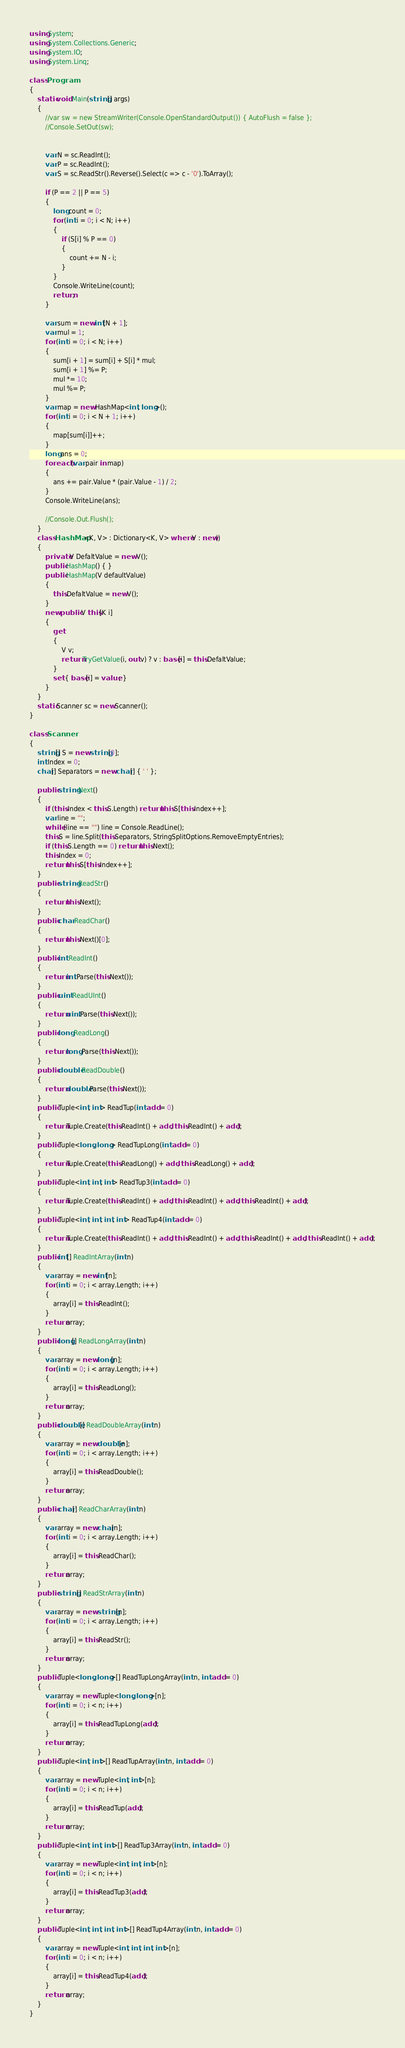<code> <loc_0><loc_0><loc_500><loc_500><_C#_>using System;
using System.Collections.Generic;
using System.IO;
using System.Linq;

class Program
{
    static void Main(string[] args)
    {
        //var sw = new StreamWriter(Console.OpenStandardOutput()) { AutoFlush = false };
        //Console.SetOut(sw);


        var N = sc.ReadInt();
        var P = sc.ReadInt();
        var S = sc.ReadStr().Reverse().Select(c => c - '0').ToArray();

        if (P == 2 || P == 5)
        {
            long count = 0;
            for (int i = 0; i < N; i++)
            {
                if (S[i] % P == 0)
                {
                    count += N - i;
                }
            }
            Console.WriteLine(count);
            return;
        }

        var sum = new int[N + 1];
        var mul = 1;
        for (int i = 0; i < N; i++)
        {
            sum[i + 1] = sum[i] + S[i] * mul;
            sum[i + 1] %= P;
            mul *= 10;
            mul %= P;
        }
        var map = new HashMap<int, long>();
        for (int i = 0; i < N + 1; i++)
        {
            map[sum[i]]++;
        }
        long ans = 0;
        foreach (var pair in map)
        {
            ans += pair.Value * (pair.Value - 1) / 2;
        }
        Console.WriteLine(ans);

        //Console.Out.Flush();
    }
    class HashMap<K, V> : Dictionary<K, V> where V : new()
    {
        private V DefaltValue = new V();
        public HashMap() { }
        public HashMap(V defaultValue)
        {
            this.DefaltValue = new V();
        }
        new public V this[K i]
        {
            get
            {
                V v;
                return TryGetValue(i, out v) ? v : base[i] = this.DefaltValue;
            }
            set { base[i] = value; }
        }
    }
    static Scanner sc = new Scanner();
}

class Scanner
{
    string[] S = new string[0];
    int Index = 0;
    char[] Separators = new char[] { ' ' };

    public string Next()
    {
        if (this.Index < this.S.Length) return this.S[this.Index++];
        var line = "";
        while (line == "") line = Console.ReadLine();
        this.S = line.Split(this.Separators, StringSplitOptions.RemoveEmptyEntries);
        if (this.S.Length == 0) return this.Next();
        this.Index = 0;
        return this.S[this.Index++];
    }
    public string ReadStr()
    {
        return this.Next();
    }
    public char ReadChar()
    {
        return this.Next()[0];
    }
    public int ReadInt()
    {
        return int.Parse(this.Next());
    }
    public uint ReadUInt()
    {
        return uint.Parse(this.Next());
    }
    public long ReadLong()
    {
        return long.Parse(this.Next());
    }
    public double ReadDouble()
    {
        return double.Parse(this.Next());
    }
    public Tuple<int, int> ReadTup(int add = 0)
    {
        return Tuple.Create(this.ReadInt() + add, this.ReadInt() + add);
    }
    public Tuple<long, long> ReadTupLong(int add = 0)
    {
        return Tuple.Create(this.ReadLong() + add, this.ReadLong() + add);
    }
    public Tuple<int, int, int> ReadTup3(int add = 0)
    {
        return Tuple.Create(this.ReadInt() + add, this.ReadInt() + add, this.ReadInt() + add);
    }
    public Tuple<int, int, int, int> ReadTup4(int add = 0)
    {
        return Tuple.Create(this.ReadInt() + add, this.ReadInt() + add, this.ReadInt() + add, this.ReadInt() + add);
    }
    public int[] ReadIntArray(int n)
    {
        var array = new int[n];
        for (int i = 0; i < array.Length; i++)
        {
            array[i] = this.ReadInt();
        }
        return array;
    }
    public long[] ReadLongArray(int n)
    {
        var array = new long[n];
        for (int i = 0; i < array.Length; i++)
        {
            array[i] = this.ReadLong();
        }
        return array;
    }
    public double[] ReadDoubleArray(int n)
    {
        var array = new double[n];
        for (int i = 0; i < array.Length; i++)
        {
            array[i] = this.ReadDouble();
        }
        return array;
    }
    public char[] ReadCharArray(int n)
    {
        var array = new char[n];
        for (int i = 0; i < array.Length; i++)
        {
            array[i] = this.ReadChar();
        }
        return array;
    }
    public string[] ReadStrArray(int n)
    {
        var array = new string[n];
        for (int i = 0; i < array.Length; i++)
        {
            array[i] = this.ReadStr();
        }
        return array;
    }
    public Tuple<long, long>[] ReadTupLongArray(int n, int add = 0)
    {
        var array = new Tuple<long, long>[n];
        for (int i = 0; i < n; i++)
        {
            array[i] = this.ReadTupLong(add);
        }
        return array;
    }
    public Tuple<int, int>[] ReadTupArray(int n, int add = 0)
    {
        var array = new Tuple<int, int>[n];
        for (int i = 0; i < n; i++)
        {
            array[i] = this.ReadTup(add);
        }
        return array;
    }
    public Tuple<int, int, int>[] ReadTup3Array(int n, int add = 0)
    {
        var array = new Tuple<int, int, int>[n];
        for (int i = 0; i < n; i++)
        {
            array[i] = this.ReadTup3(add);
        }
        return array;
    }
    public Tuple<int, int, int, int>[] ReadTup4Array(int n, int add = 0)
    {
        var array = new Tuple<int, int, int, int>[n];
        for (int i = 0; i < n; i++)
        {
            array[i] = this.ReadTup4(add);
        }
        return array;
    }
}
</code> 